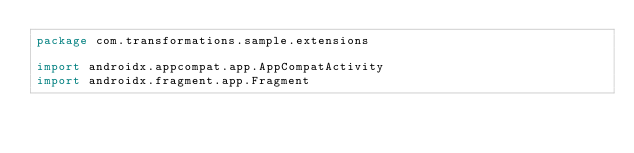<code> <loc_0><loc_0><loc_500><loc_500><_Kotlin_>package com.transformations.sample.extensions

import androidx.appcompat.app.AppCompatActivity
import androidx.fragment.app.Fragment</code> 